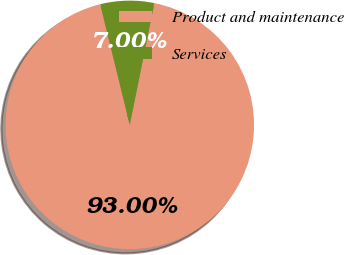<chart> <loc_0><loc_0><loc_500><loc_500><pie_chart><fcel>Product and maintenance<fcel>Services<nl><fcel>93.0%<fcel>7.0%<nl></chart> 